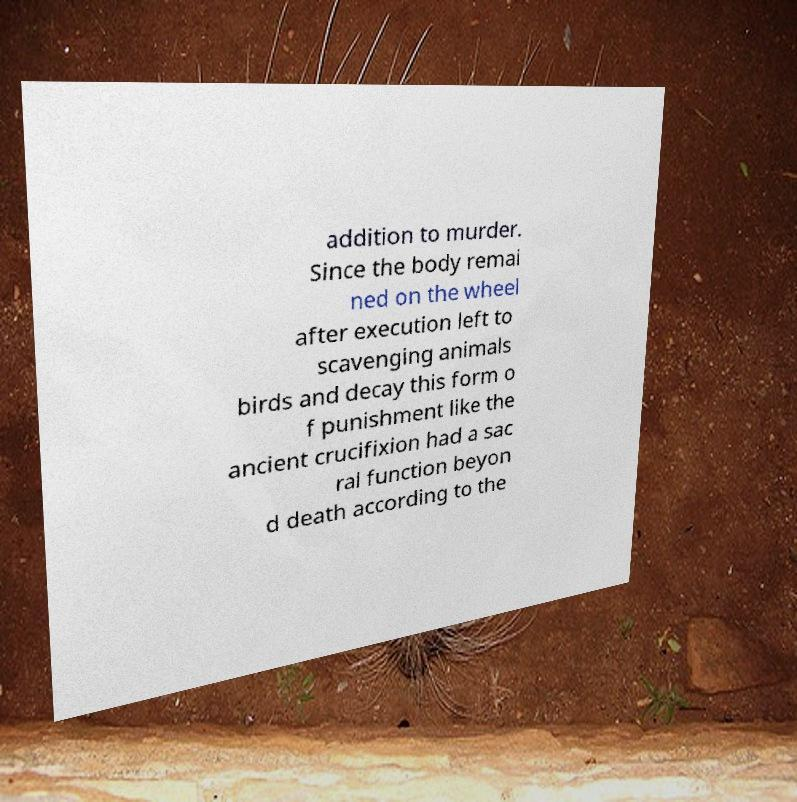There's text embedded in this image that I need extracted. Can you transcribe it verbatim? addition to murder. Since the body remai ned on the wheel after execution left to scavenging animals birds and decay this form o f punishment like the ancient crucifixion had a sac ral function beyon d death according to the 